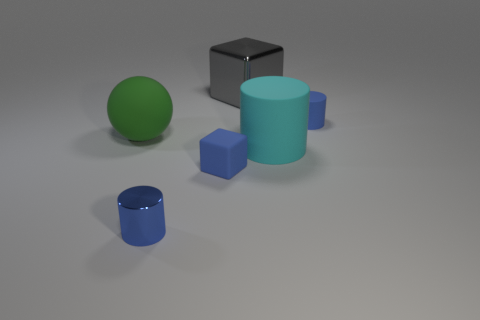What shape is the tiny rubber thing that is behind the green rubber ball?
Keep it short and to the point. Cylinder. How many other balls are the same material as the green ball?
Provide a short and direct response. 0. There is a small metallic thing; is it the same shape as the large cyan rubber object right of the blue metallic thing?
Your response must be concise. Yes. Is there a gray metallic cube that is right of the tiny blue cylinder to the left of the gray shiny object that is behind the big green object?
Keep it short and to the point. Yes. There is a blue cylinder to the right of the large cube; what is its size?
Give a very brief answer. Small. There is a cyan cylinder that is the same size as the rubber sphere; what is its material?
Your response must be concise. Rubber. Do the large cyan matte object and the big green rubber object have the same shape?
Provide a short and direct response. No. How many things are blue shiny cylinders or big things that are right of the large gray thing?
Provide a succinct answer. 2. There is another small cylinder that is the same color as the tiny shiny cylinder; what is its material?
Provide a short and direct response. Rubber. There is a block that is to the left of the gray metal block; is it the same size as the blue matte cylinder?
Your answer should be compact. Yes. 